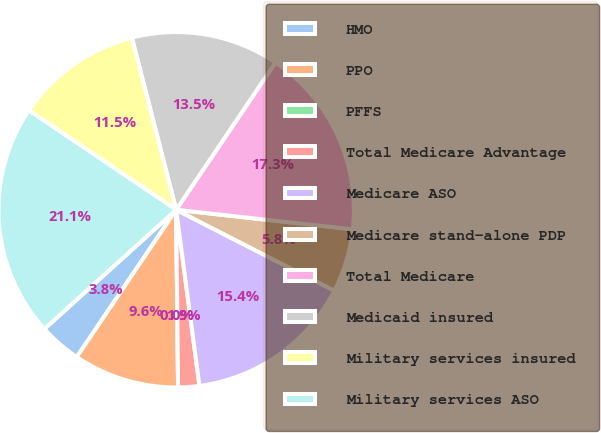Convert chart. <chart><loc_0><loc_0><loc_500><loc_500><pie_chart><fcel>HMO<fcel>PPO<fcel>PFFS<fcel>Total Medicare Advantage<fcel>Medicare ASO<fcel>Medicare stand-alone PDP<fcel>Total Medicare<fcel>Medicaid insured<fcel>Military services insured<fcel>Military services ASO<nl><fcel>3.85%<fcel>9.62%<fcel>0.0%<fcel>1.92%<fcel>15.38%<fcel>5.77%<fcel>17.31%<fcel>13.46%<fcel>11.54%<fcel>21.15%<nl></chart> 